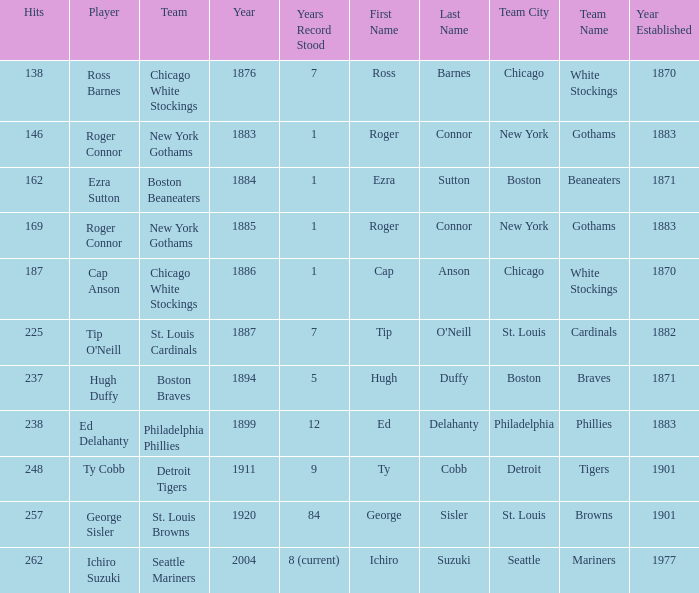List the popular songs from years prior to 188 138.0. 